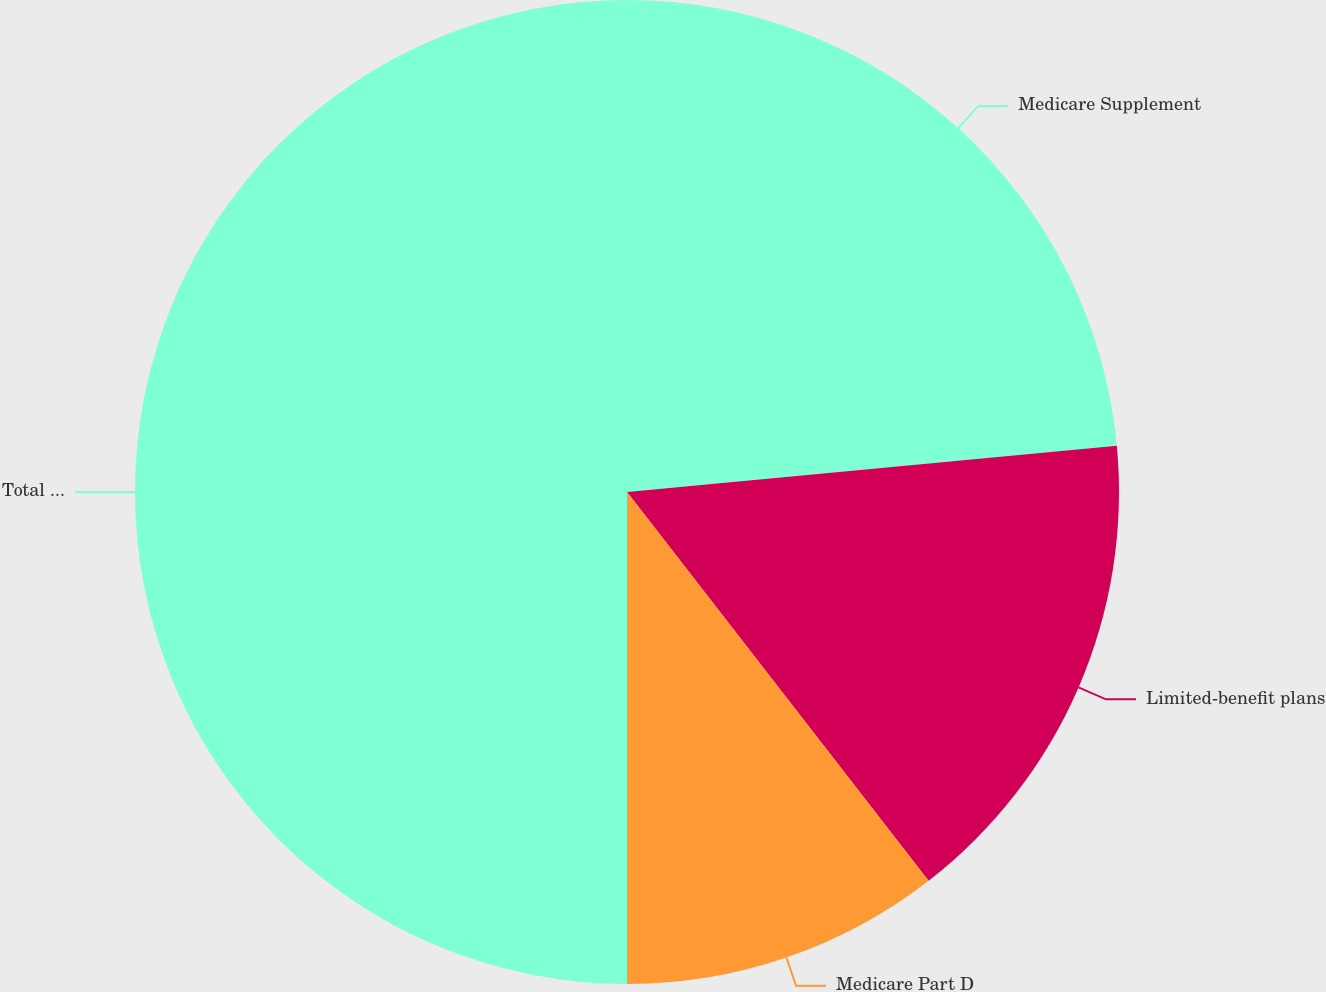Convert chart to OTSL. <chart><loc_0><loc_0><loc_500><loc_500><pie_chart><fcel>Medicare Supplement<fcel>Limited-benefit plans<fcel>Medicare Part D<fcel>Total Health<nl><fcel>23.5%<fcel>16.0%<fcel>10.5%<fcel>50.0%<nl></chart> 